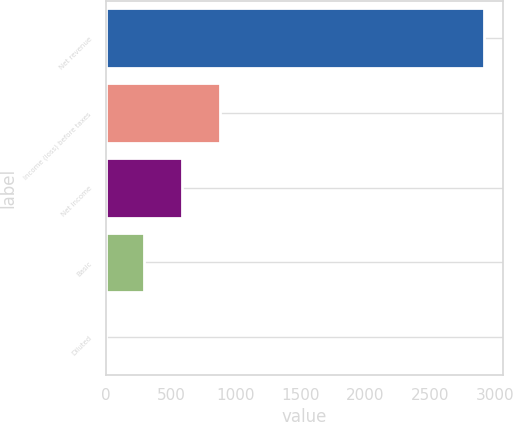Convert chart to OTSL. <chart><loc_0><loc_0><loc_500><loc_500><bar_chart><fcel>Net revenue<fcel>Income (loss) before taxes<fcel>Net income<fcel>Basic<fcel>Diluted<nl><fcel>2918<fcel>876.76<fcel>585.16<fcel>293.56<fcel>1.95<nl></chart> 